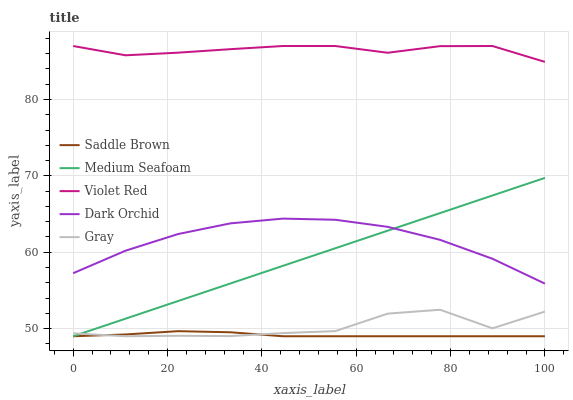Does Saddle Brown have the minimum area under the curve?
Answer yes or no. Yes. Does Violet Red have the maximum area under the curve?
Answer yes or no. Yes. Does Violet Red have the minimum area under the curve?
Answer yes or no. No. Does Saddle Brown have the maximum area under the curve?
Answer yes or no. No. Is Medium Seafoam the smoothest?
Answer yes or no. Yes. Is Gray the roughest?
Answer yes or no. Yes. Is Violet Red the smoothest?
Answer yes or no. No. Is Violet Red the roughest?
Answer yes or no. No. Does Gray have the lowest value?
Answer yes or no. Yes. Does Violet Red have the lowest value?
Answer yes or no. No. Does Violet Red have the highest value?
Answer yes or no. Yes. Does Saddle Brown have the highest value?
Answer yes or no. No. Is Saddle Brown less than Violet Red?
Answer yes or no. Yes. Is Dark Orchid greater than Saddle Brown?
Answer yes or no. Yes. Does Saddle Brown intersect Medium Seafoam?
Answer yes or no. Yes. Is Saddle Brown less than Medium Seafoam?
Answer yes or no. No. Is Saddle Brown greater than Medium Seafoam?
Answer yes or no. No. Does Saddle Brown intersect Violet Red?
Answer yes or no. No. 